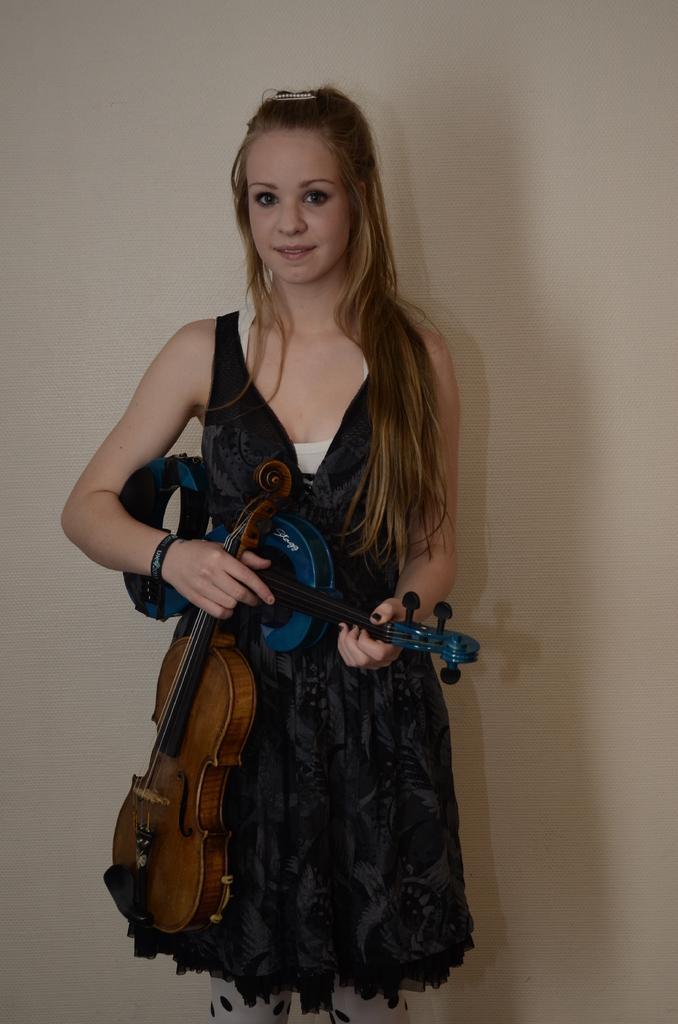Could you give a brief overview of what you see in this image? In this image, there is a lady standing and holding two guitars which are light yellow and blue in color. In the background there is a wall which is white in color. This image is taken inside a house. 